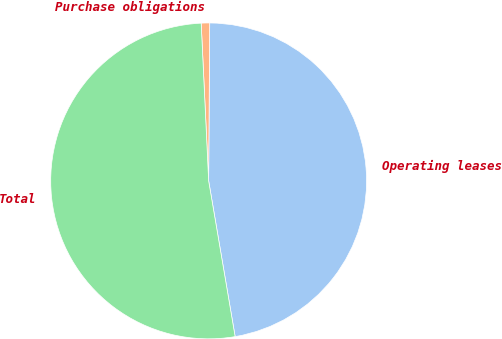Convert chart to OTSL. <chart><loc_0><loc_0><loc_500><loc_500><pie_chart><fcel>Operating leases<fcel>Purchase obligations<fcel>Total<nl><fcel>47.21%<fcel>0.86%<fcel>51.93%<nl></chart> 